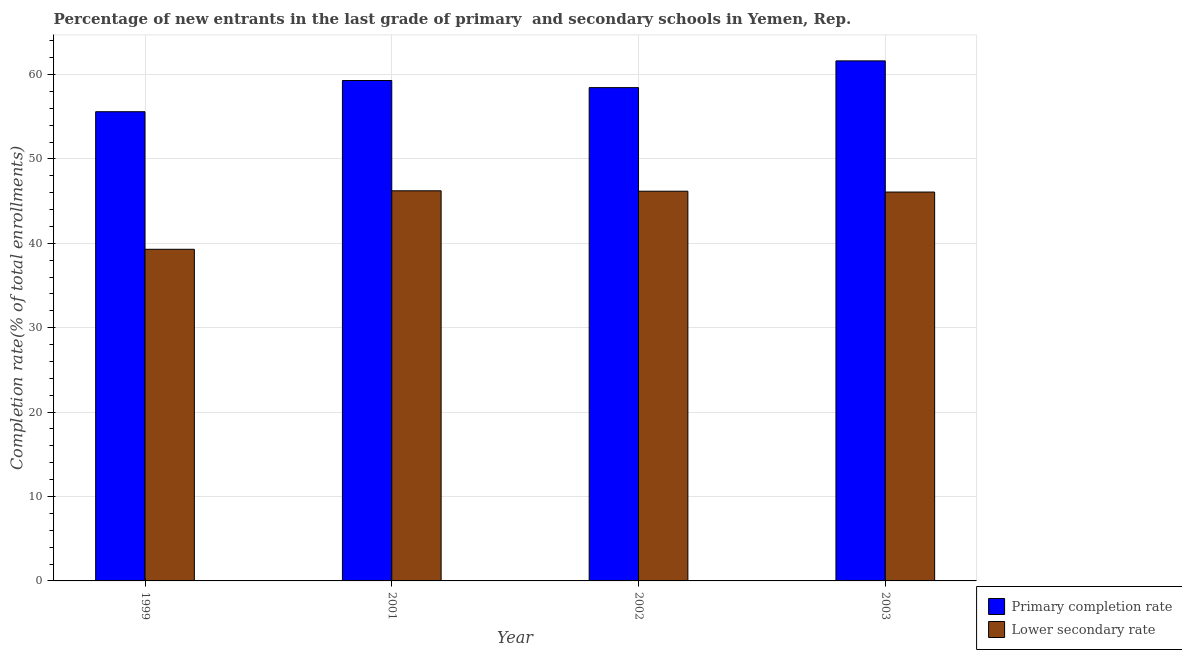Are the number of bars per tick equal to the number of legend labels?
Your answer should be very brief. Yes. Are the number of bars on each tick of the X-axis equal?
Your response must be concise. Yes. How many bars are there on the 1st tick from the right?
Give a very brief answer. 2. What is the label of the 1st group of bars from the left?
Give a very brief answer. 1999. In how many cases, is the number of bars for a given year not equal to the number of legend labels?
Your answer should be compact. 0. What is the completion rate in secondary schools in 2001?
Your answer should be very brief. 46.22. Across all years, what is the maximum completion rate in secondary schools?
Ensure brevity in your answer.  46.22. Across all years, what is the minimum completion rate in secondary schools?
Provide a succinct answer. 39.29. In which year was the completion rate in primary schools minimum?
Your answer should be very brief. 1999. What is the total completion rate in secondary schools in the graph?
Offer a very short reply. 177.75. What is the difference between the completion rate in secondary schools in 1999 and that in 2002?
Make the answer very short. -6.88. What is the difference between the completion rate in primary schools in 2002 and the completion rate in secondary schools in 1999?
Your answer should be very brief. 2.85. What is the average completion rate in primary schools per year?
Your answer should be very brief. 58.73. In the year 1999, what is the difference between the completion rate in primary schools and completion rate in secondary schools?
Your answer should be very brief. 0. In how many years, is the completion rate in secondary schools greater than 24 %?
Keep it short and to the point. 4. What is the ratio of the completion rate in secondary schools in 2002 to that in 2003?
Keep it short and to the point. 1. What is the difference between the highest and the second highest completion rate in primary schools?
Your answer should be compact. 2.33. What is the difference between the highest and the lowest completion rate in secondary schools?
Offer a terse response. 6.93. Is the sum of the completion rate in primary schools in 2001 and 2002 greater than the maximum completion rate in secondary schools across all years?
Offer a terse response. Yes. What does the 2nd bar from the left in 2002 represents?
Make the answer very short. Lower secondary rate. What does the 1st bar from the right in 2003 represents?
Ensure brevity in your answer.  Lower secondary rate. How many bars are there?
Your answer should be compact. 8. How many years are there in the graph?
Your answer should be very brief. 4. Are the values on the major ticks of Y-axis written in scientific E-notation?
Provide a short and direct response. No. Where does the legend appear in the graph?
Ensure brevity in your answer.  Bottom right. How many legend labels are there?
Provide a short and direct response. 2. How are the legend labels stacked?
Your response must be concise. Vertical. What is the title of the graph?
Provide a succinct answer. Percentage of new entrants in the last grade of primary  and secondary schools in Yemen, Rep. Does "Adolescent fertility rate" appear as one of the legend labels in the graph?
Your answer should be very brief. No. What is the label or title of the X-axis?
Offer a very short reply. Year. What is the label or title of the Y-axis?
Offer a very short reply. Completion rate(% of total enrollments). What is the Completion rate(% of total enrollments) of Primary completion rate in 1999?
Make the answer very short. 55.59. What is the Completion rate(% of total enrollments) of Lower secondary rate in 1999?
Keep it short and to the point. 39.29. What is the Completion rate(% of total enrollments) in Primary completion rate in 2001?
Ensure brevity in your answer.  59.29. What is the Completion rate(% of total enrollments) of Lower secondary rate in 2001?
Keep it short and to the point. 46.22. What is the Completion rate(% of total enrollments) in Primary completion rate in 2002?
Give a very brief answer. 58.44. What is the Completion rate(% of total enrollments) in Lower secondary rate in 2002?
Your answer should be compact. 46.17. What is the Completion rate(% of total enrollments) in Primary completion rate in 2003?
Make the answer very short. 61.61. What is the Completion rate(% of total enrollments) in Lower secondary rate in 2003?
Keep it short and to the point. 46.07. Across all years, what is the maximum Completion rate(% of total enrollments) in Primary completion rate?
Make the answer very short. 61.61. Across all years, what is the maximum Completion rate(% of total enrollments) in Lower secondary rate?
Make the answer very short. 46.22. Across all years, what is the minimum Completion rate(% of total enrollments) in Primary completion rate?
Your answer should be compact. 55.59. Across all years, what is the minimum Completion rate(% of total enrollments) of Lower secondary rate?
Your response must be concise. 39.29. What is the total Completion rate(% of total enrollments) in Primary completion rate in the graph?
Provide a short and direct response. 234.93. What is the total Completion rate(% of total enrollments) in Lower secondary rate in the graph?
Provide a succinct answer. 177.75. What is the difference between the Completion rate(% of total enrollments) in Primary completion rate in 1999 and that in 2001?
Your answer should be very brief. -3.7. What is the difference between the Completion rate(% of total enrollments) of Lower secondary rate in 1999 and that in 2001?
Make the answer very short. -6.93. What is the difference between the Completion rate(% of total enrollments) in Primary completion rate in 1999 and that in 2002?
Offer a terse response. -2.85. What is the difference between the Completion rate(% of total enrollments) in Lower secondary rate in 1999 and that in 2002?
Keep it short and to the point. -6.88. What is the difference between the Completion rate(% of total enrollments) in Primary completion rate in 1999 and that in 2003?
Your response must be concise. -6.02. What is the difference between the Completion rate(% of total enrollments) in Lower secondary rate in 1999 and that in 2003?
Ensure brevity in your answer.  -6.78. What is the difference between the Completion rate(% of total enrollments) of Primary completion rate in 2001 and that in 2002?
Provide a short and direct response. 0.85. What is the difference between the Completion rate(% of total enrollments) of Lower secondary rate in 2001 and that in 2002?
Provide a succinct answer. 0.05. What is the difference between the Completion rate(% of total enrollments) of Primary completion rate in 2001 and that in 2003?
Your answer should be compact. -2.33. What is the difference between the Completion rate(% of total enrollments) in Lower secondary rate in 2001 and that in 2003?
Ensure brevity in your answer.  0.15. What is the difference between the Completion rate(% of total enrollments) in Primary completion rate in 2002 and that in 2003?
Offer a terse response. -3.17. What is the difference between the Completion rate(% of total enrollments) in Lower secondary rate in 2002 and that in 2003?
Make the answer very short. 0.1. What is the difference between the Completion rate(% of total enrollments) in Primary completion rate in 1999 and the Completion rate(% of total enrollments) in Lower secondary rate in 2001?
Your answer should be compact. 9.37. What is the difference between the Completion rate(% of total enrollments) in Primary completion rate in 1999 and the Completion rate(% of total enrollments) in Lower secondary rate in 2002?
Give a very brief answer. 9.42. What is the difference between the Completion rate(% of total enrollments) of Primary completion rate in 1999 and the Completion rate(% of total enrollments) of Lower secondary rate in 2003?
Your response must be concise. 9.52. What is the difference between the Completion rate(% of total enrollments) of Primary completion rate in 2001 and the Completion rate(% of total enrollments) of Lower secondary rate in 2002?
Offer a terse response. 13.12. What is the difference between the Completion rate(% of total enrollments) of Primary completion rate in 2001 and the Completion rate(% of total enrollments) of Lower secondary rate in 2003?
Provide a short and direct response. 13.22. What is the difference between the Completion rate(% of total enrollments) of Primary completion rate in 2002 and the Completion rate(% of total enrollments) of Lower secondary rate in 2003?
Ensure brevity in your answer.  12.37. What is the average Completion rate(% of total enrollments) in Primary completion rate per year?
Give a very brief answer. 58.73. What is the average Completion rate(% of total enrollments) of Lower secondary rate per year?
Keep it short and to the point. 44.44. In the year 1999, what is the difference between the Completion rate(% of total enrollments) in Primary completion rate and Completion rate(% of total enrollments) in Lower secondary rate?
Your answer should be compact. 16.3. In the year 2001, what is the difference between the Completion rate(% of total enrollments) in Primary completion rate and Completion rate(% of total enrollments) in Lower secondary rate?
Your answer should be very brief. 13.07. In the year 2002, what is the difference between the Completion rate(% of total enrollments) in Primary completion rate and Completion rate(% of total enrollments) in Lower secondary rate?
Keep it short and to the point. 12.27. In the year 2003, what is the difference between the Completion rate(% of total enrollments) of Primary completion rate and Completion rate(% of total enrollments) of Lower secondary rate?
Offer a very short reply. 15.54. What is the ratio of the Completion rate(% of total enrollments) in Primary completion rate in 1999 to that in 2001?
Provide a succinct answer. 0.94. What is the ratio of the Completion rate(% of total enrollments) of Lower secondary rate in 1999 to that in 2001?
Provide a succinct answer. 0.85. What is the ratio of the Completion rate(% of total enrollments) of Primary completion rate in 1999 to that in 2002?
Your answer should be compact. 0.95. What is the ratio of the Completion rate(% of total enrollments) in Lower secondary rate in 1999 to that in 2002?
Keep it short and to the point. 0.85. What is the ratio of the Completion rate(% of total enrollments) in Primary completion rate in 1999 to that in 2003?
Your answer should be compact. 0.9. What is the ratio of the Completion rate(% of total enrollments) of Lower secondary rate in 1999 to that in 2003?
Your answer should be compact. 0.85. What is the ratio of the Completion rate(% of total enrollments) in Primary completion rate in 2001 to that in 2002?
Offer a very short reply. 1.01. What is the ratio of the Completion rate(% of total enrollments) in Primary completion rate in 2001 to that in 2003?
Offer a terse response. 0.96. What is the ratio of the Completion rate(% of total enrollments) in Primary completion rate in 2002 to that in 2003?
Offer a very short reply. 0.95. What is the difference between the highest and the second highest Completion rate(% of total enrollments) of Primary completion rate?
Provide a succinct answer. 2.33. What is the difference between the highest and the second highest Completion rate(% of total enrollments) in Lower secondary rate?
Make the answer very short. 0.05. What is the difference between the highest and the lowest Completion rate(% of total enrollments) in Primary completion rate?
Your answer should be compact. 6.02. What is the difference between the highest and the lowest Completion rate(% of total enrollments) in Lower secondary rate?
Your response must be concise. 6.93. 